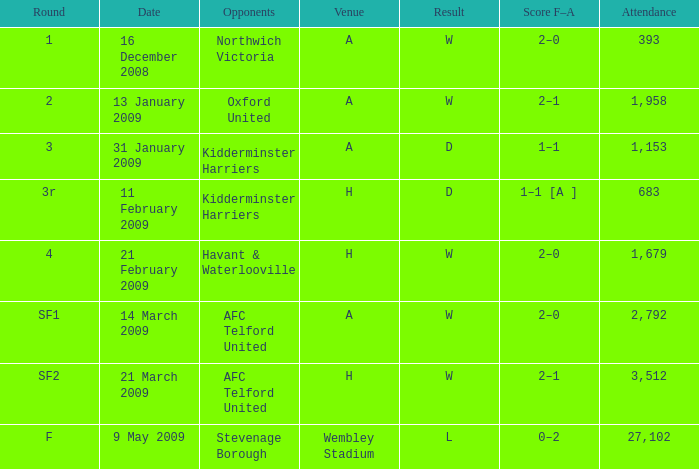Which round happened on the 21st of february, 2009? 4.0. 